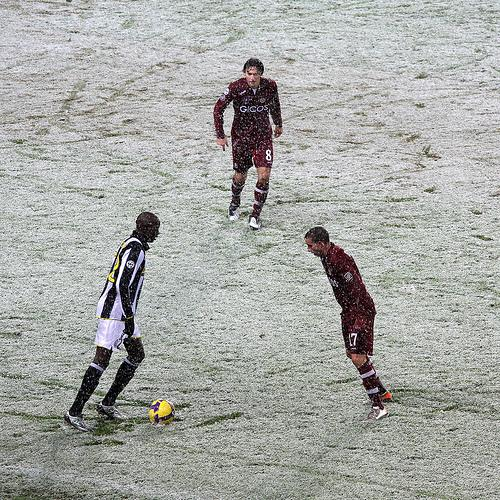Do any of the men appear to be bald or have a notable hairstyle? Yes, one man appears to have a bald head, while another man has a distinctive hair. What colors are the socks that two of the men are wearing? One man is wearing black knee socks with a white edge, and another is wearing maroon socks with white stripes. Analyze the interactions between the objects and/or people in the image. The men in the image are interacting with each other and the yellow and purple soccer ball, while running and maneuvering on the flooded soccer field amidst snowy conditions. Describe the sentiment or atmosphere in the image. The atmosphere seems to be intense and challenging, as the men are playing soccer in difficult weather conditions, including rain and snow on a flooded field. Describe the soccer ball in the image. The soccer ball is yellow and purple in color. What color is the man in red shorts wearing a uniform of? The man in red shorts is wearing a maroon soccer uniform. What different uniform designs can be identified in the image? There are maroon, black and white, and white and black uniforms, with team logos, white letters across the shirts, and yellow prints on striped shirts. What is unusual about the setting of the soccer game in the image? The unusual setting is that the soccer game is happening on a flooded field, and it appears to be snowing as well. How many men are visible in the image? There are at least three men visible in the image. Briefly describe the overall scene in the image. The image showcases a flooded soccer field with multiple men playing soccer in the snow, wearing different uniforms and interacting with a yellow and purple soccer ball. 